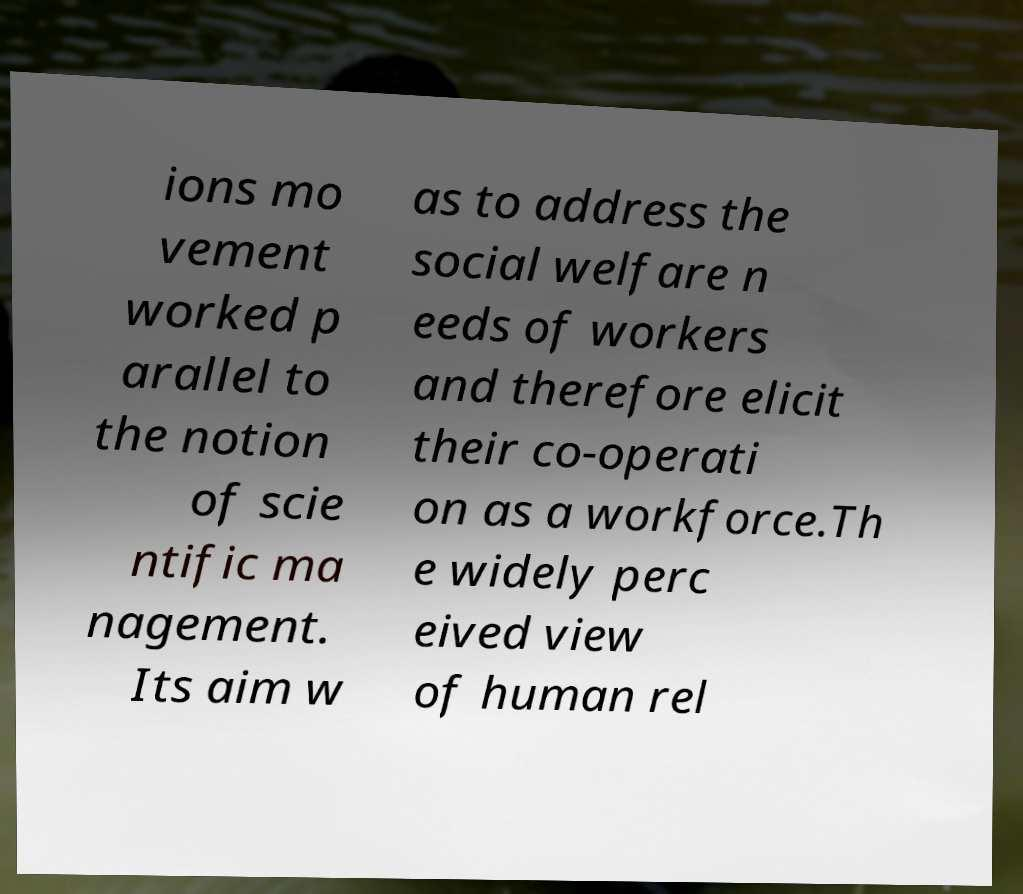Could you assist in decoding the text presented in this image and type it out clearly? ions mo vement worked p arallel to the notion of scie ntific ma nagement. Its aim w as to address the social welfare n eeds of workers and therefore elicit their co-operati on as a workforce.Th e widely perc eived view of human rel 